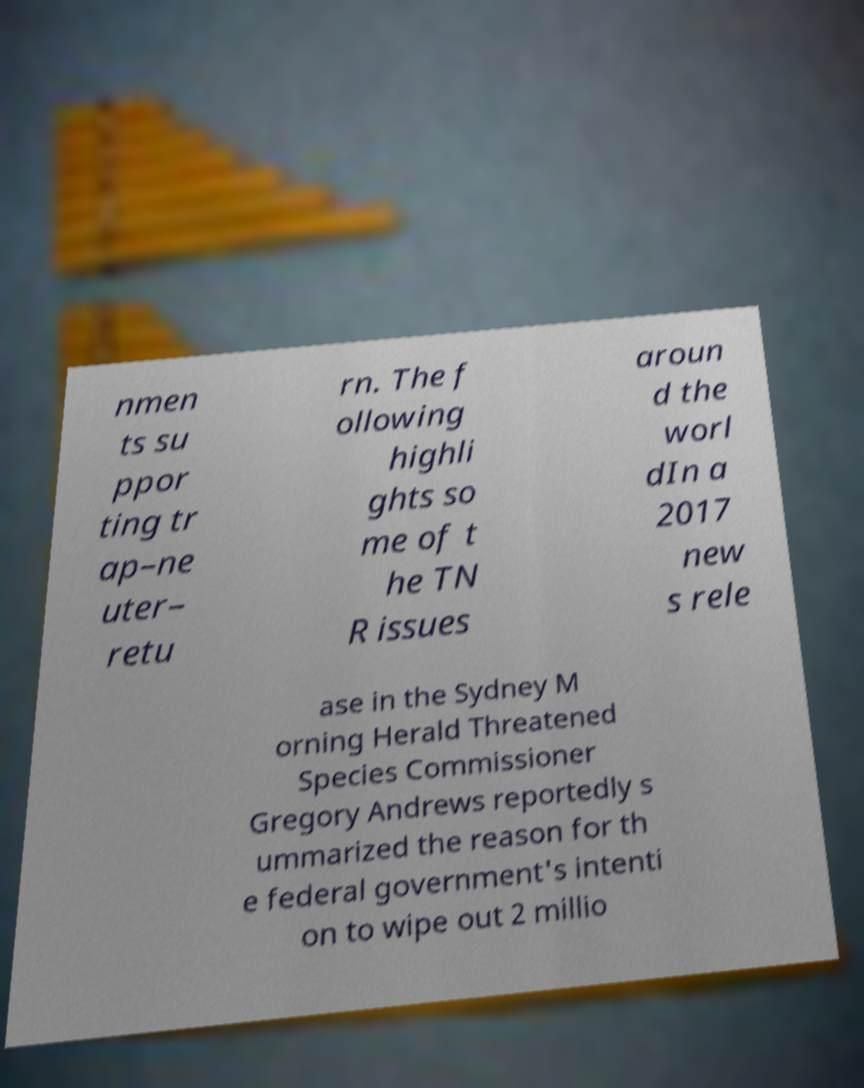Please identify and transcribe the text found in this image. nmen ts su ppor ting tr ap–ne uter– retu rn. The f ollowing highli ghts so me of t he TN R issues aroun d the worl dIn a 2017 new s rele ase in the Sydney M orning Herald Threatened Species Commissioner Gregory Andrews reportedly s ummarized the reason for th e federal government's intenti on to wipe out 2 millio 